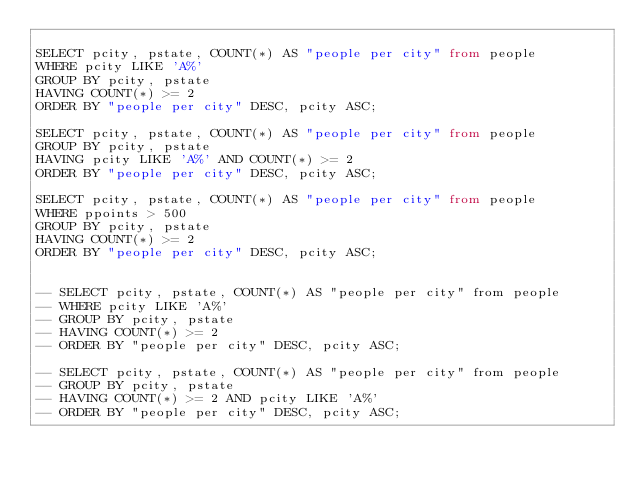Convert code to text. <code><loc_0><loc_0><loc_500><loc_500><_SQL_>
SELECT pcity, pstate, COUNT(*) AS "people per city" from people 
WHERE pcity LIKE 'A%'
GROUP BY pcity, pstate 
HAVING COUNT(*) >= 2
ORDER BY "people per city" DESC, pcity ASC;

SELECT pcity, pstate, COUNT(*) AS "people per city" from people 
GROUP BY pcity, pstate 
HAVING pcity LIKE 'A%' AND COUNT(*) >= 2
ORDER BY "people per city" DESC, pcity ASC;

SELECT pcity, pstate, COUNT(*) AS "people per city" from people 
WHERE ppoints > 500
GROUP BY pcity, pstate 
HAVING COUNT(*) >= 2
ORDER BY "people per city" DESC, pcity ASC;


-- SELECT pcity, pstate, COUNT(*) AS "people per city" from people 
-- WHERE pcity LIKE 'A%'
-- GROUP BY pcity, pstate 
-- HAVING COUNT(*) >= 2
-- ORDER BY "people per city" DESC, pcity ASC;

-- SELECT pcity, pstate, COUNT(*) AS "people per city" from people 
-- GROUP BY pcity, pstate 
-- HAVING COUNT(*) >= 2 AND pcity LIKE 'A%'
-- ORDER BY "people per city" DESC, pcity ASC;</code> 